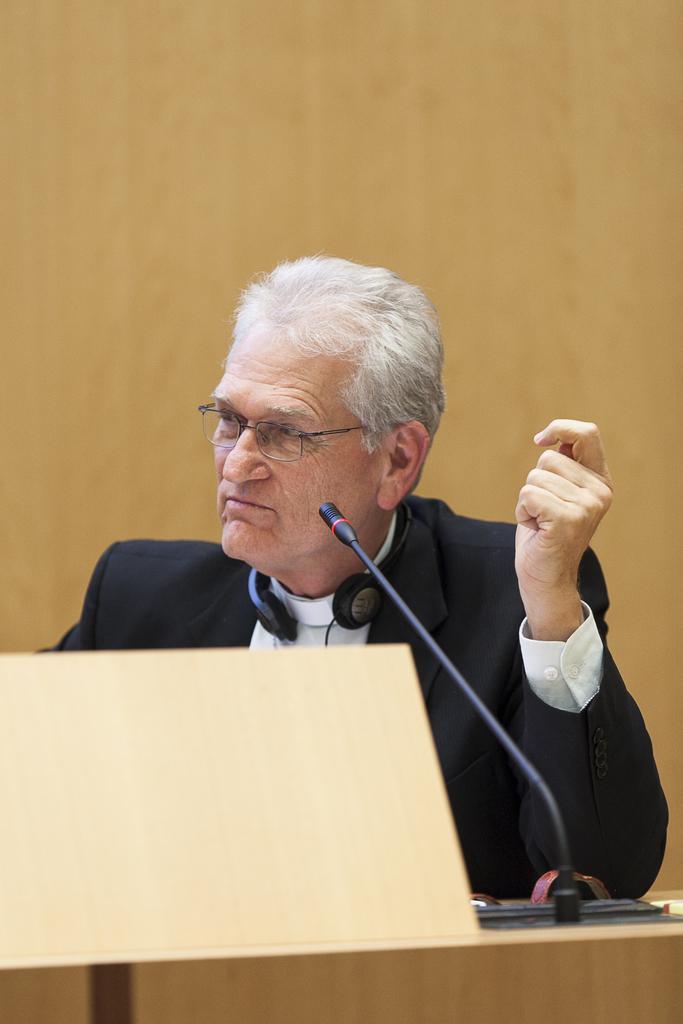In one or two sentences, can you explain what this image depicts? In this picture I can observe a person in front of a table. There is a mic on the table. The person is wearing spectacles and a coat. In the background there is a cream color wall. 